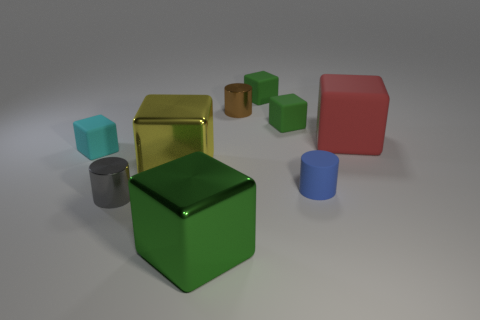Can you describe the size and color comparison between the objects in the image? Certainly! The image showcases a variety of geometric shapes. The largest object appears to be a red, matte cube, whereas the smallest is a tiny cyan one with a similar cubical shape. There's also a reflective gold cube and a metallic cylinder. The colors range from metallic shades to matte solids like red, green, cyan, gold, and a brownish cube in the background. 